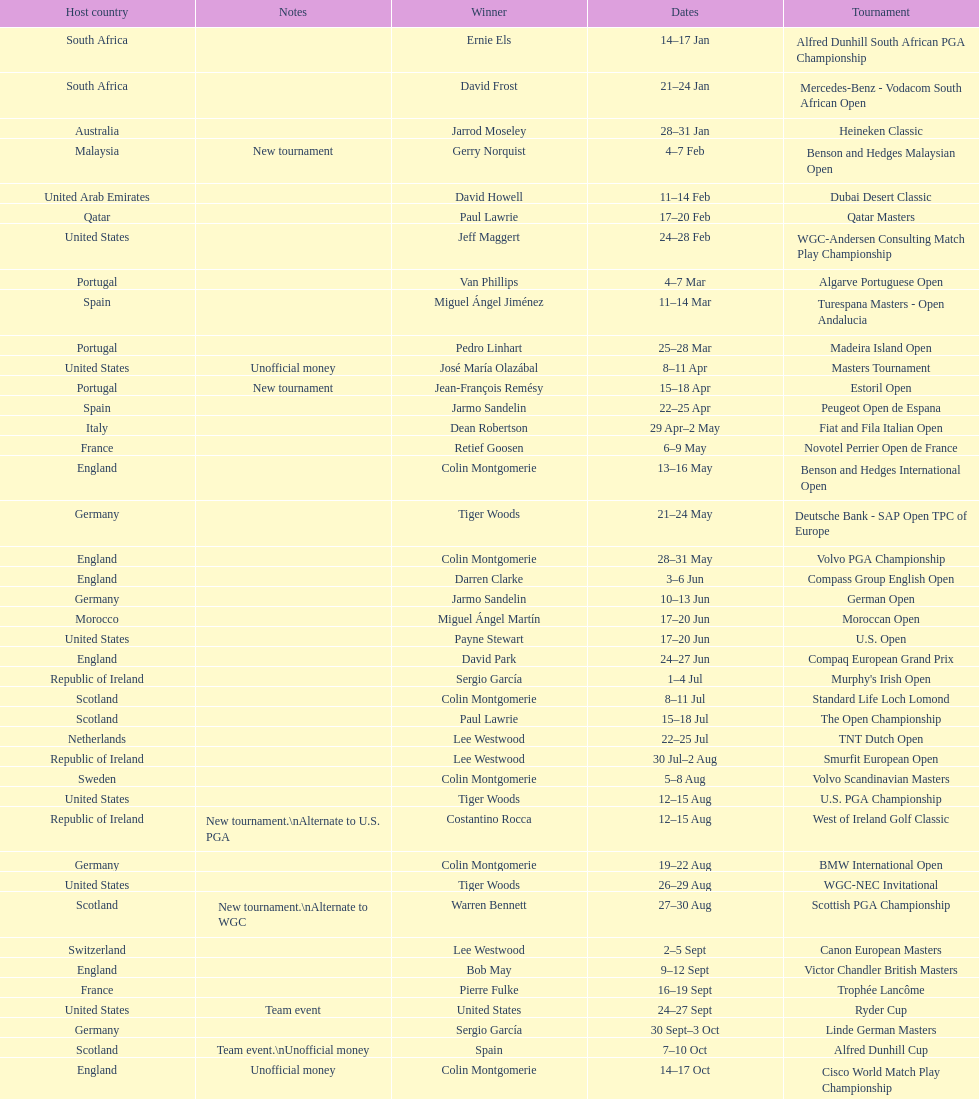How many tournaments began before aug 15th 31. 